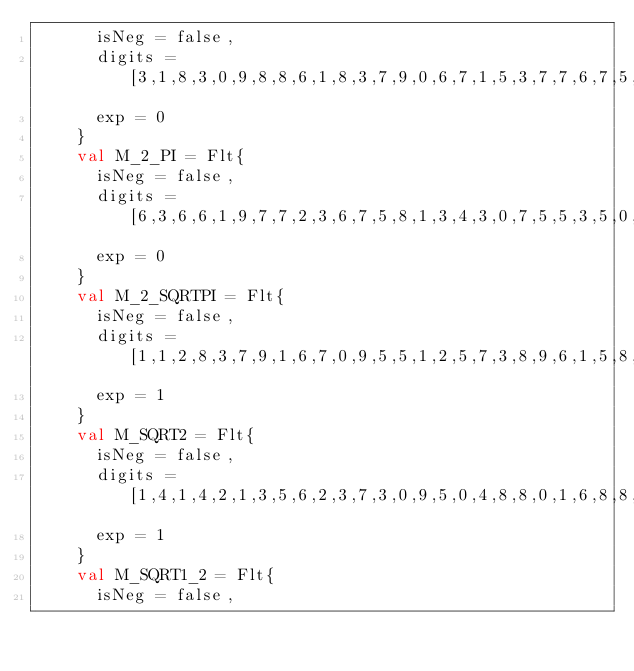<code> <loc_0><loc_0><loc_500><loc_500><_SML_>	    isNeg = false,
	    digits = [3,1,8,3,0,9,8,8,6,1,8,3,7,9,0,6,7,1,5,3,7,7,6,7,5,2,6,7,4,5,0,2,8,7,2,4],
	    exp = 0
	  }
    val M_2_PI = Flt{
	    isNeg = false,
	    digits = [6,3,6,6,1,9,7,7,2,3,6,7,5,8,1,3,4,3,0,7,5,5,3,5,0,5,3,4,9,0,0,5,7,4,4,8],
	    exp = 0
	  }
    val M_2_SQRTPI = Flt{
	    isNeg = false,
	    digits = [1,1,2,8,3,7,9,1,6,7,0,9,5,5,1,2,5,7,3,8,9,6,1,5,8,9,0,3,1,2,1,5,4,5,1,7],
	    exp = 1
	  }
    val M_SQRT2 = Flt{
	    isNeg = false,
	    digits = [1,4,1,4,2,1,3,5,6,2,3,7,3,0,9,5,0,4,8,8,0,1,6,8,8,7,2,4,2,0,9,6,9,8,0,8],
	    exp = 1
	  }
    val M_SQRT1_2 = Flt{
	    isNeg = false,</code> 